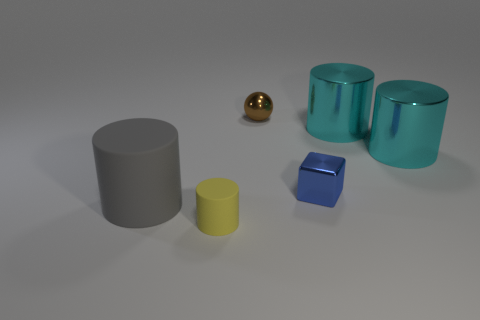Subtract all large gray cylinders. How many cylinders are left? 3 Add 2 purple matte spheres. How many objects exist? 8 Subtract all yellow cylinders. How many cylinders are left? 3 Subtract all large cyan shiny objects. Subtract all matte objects. How many objects are left? 2 Add 2 small yellow rubber cylinders. How many small yellow rubber cylinders are left? 3 Add 3 cylinders. How many cylinders exist? 7 Subtract 0 blue spheres. How many objects are left? 6 Subtract all cylinders. How many objects are left? 2 Subtract 1 spheres. How many spheres are left? 0 Subtract all red spheres. Subtract all blue cylinders. How many spheres are left? 1 